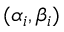<formula> <loc_0><loc_0><loc_500><loc_500>( \alpha _ { i } , \beta _ { i } )</formula> 